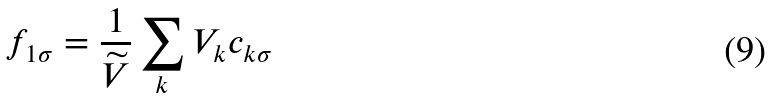<formula> <loc_0><loc_0><loc_500><loc_500>f _ { 1 \sigma } = \frac { 1 } { \widetilde { V } } \sum _ { k } V _ { k } c _ { k \sigma }</formula> 